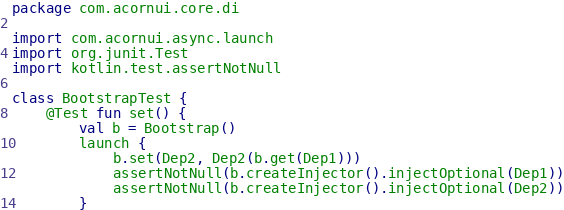<code> <loc_0><loc_0><loc_500><loc_500><_Kotlin_>package com.acornui.core.di

import com.acornui.async.launch
import org.junit.Test
import kotlin.test.assertNotNull

class BootstrapTest {
	@Test fun set() {
		val b = Bootstrap()
		launch {
			b.set(Dep2, Dep2(b.get(Dep1)))
			assertNotNull(b.createInjector().injectOptional(Dep1))
			assertNotNull(b.createInjector().injectOptional(Dep2))
		}</code> 